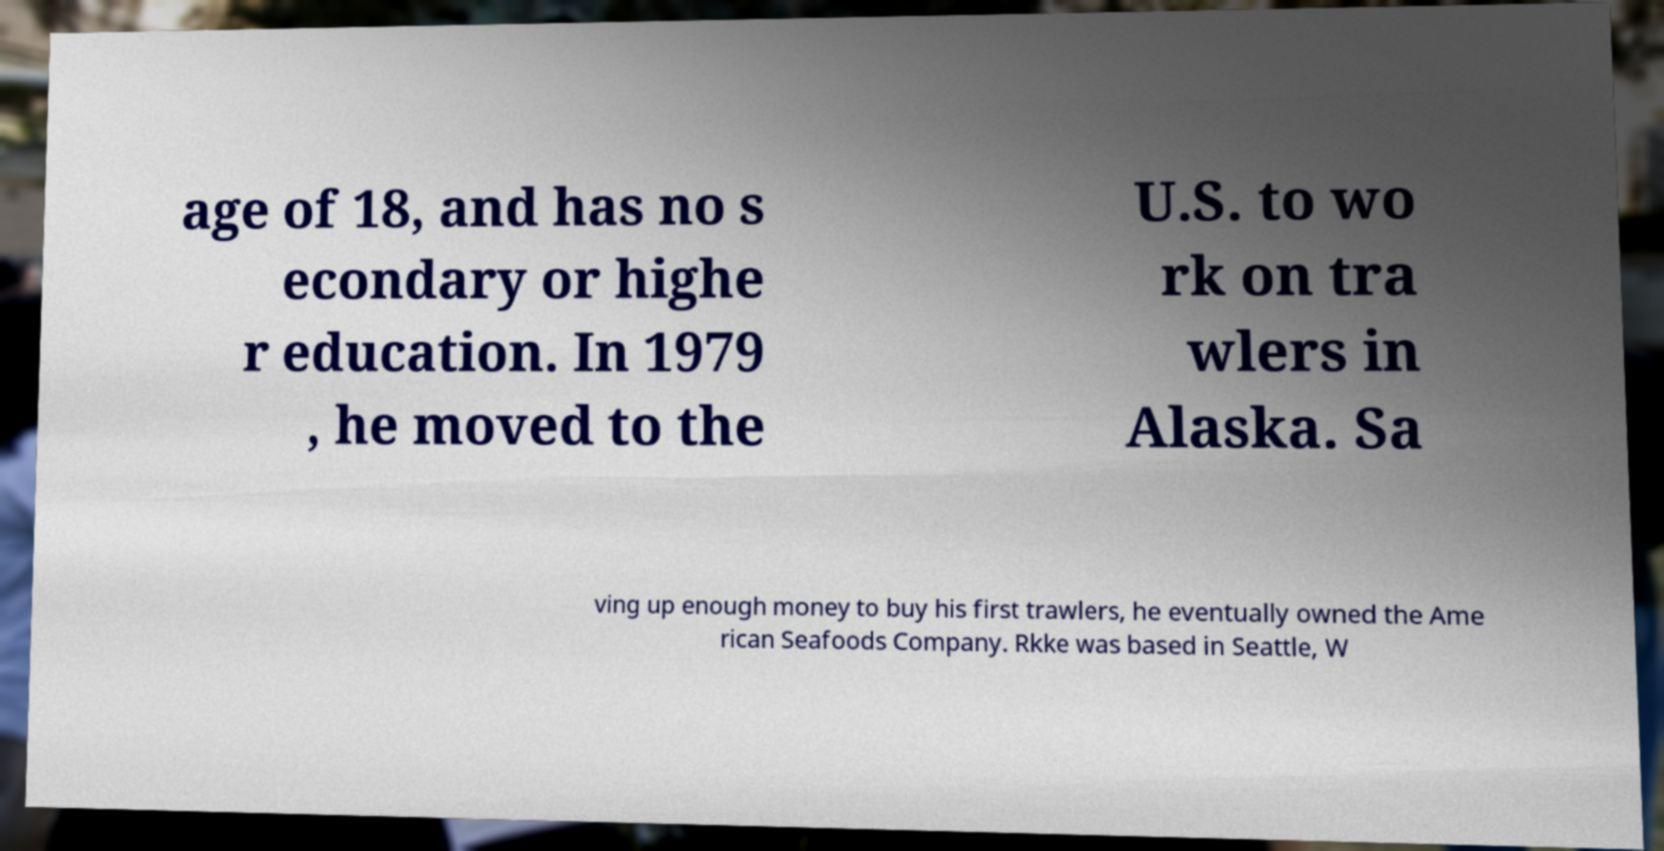Could you extract and type out the text from this image? age of 18, and has no s econdary or highe r education. In 1979 , he moved to the U.S. to wo rk on tra wlers in Alaska. Sa ving up enough money to buy his first trawlers, he eventually owned the Ame rican Seafoods Company. Rkke was based in Seattle, W 